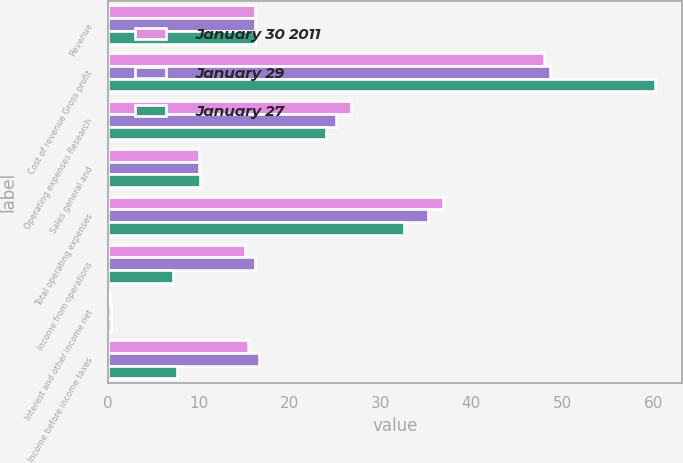Convert chart. <chart><loc_0><loc_0><loc_500><loc_500><stacked_bar_chart><ecel><fcel>Revenue<fcel>Cost of revenue Gross profit<fcel>Operating expenses Research<fcel>Sales general and<fcel>Total operating expenses<fcel>Income from operations<fcel>Interest and other income net<fcel>Income before income taxes<nl><fcel>January 30 2011<fcel>16.2<fcel>48<fcel>26.8<fcel>10.1<fcel>36.9<fcel>15.1<fcel>0.3<fcel>15.4<nl><fcel>January 29<fcel>16.2<fcel>48.6<fcel>25.1<fcel>10.1<fcel>35.2<fcel>16.2<fcel>0.4<fcel>16.6<nl><fcel>January 27<fcel>16.2<fcel>60.2<fcel>24<fcel>10.2<fcel>32.6<fcel>7.2<fcel>0.4<fcel>7.6<nl></chart> 